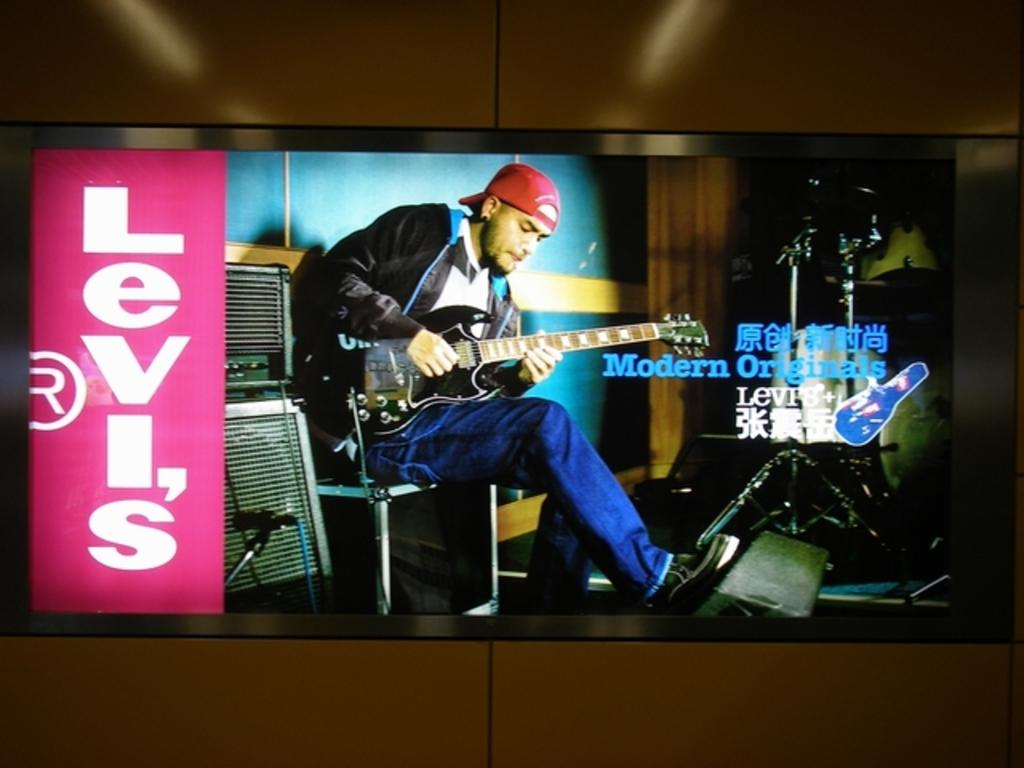What is the main object in the image? There is a screen in the image. What is happening on the screen? A person is sitting and playing guitar on the screen. What can be seen near the screen? There is a microphone in the image. What else is present in the image besides the screen and microphone? There are devices and a wall in the image. Can you see a leaf falling from the volcano in the image? There is no leaf or volcano present in the image. 